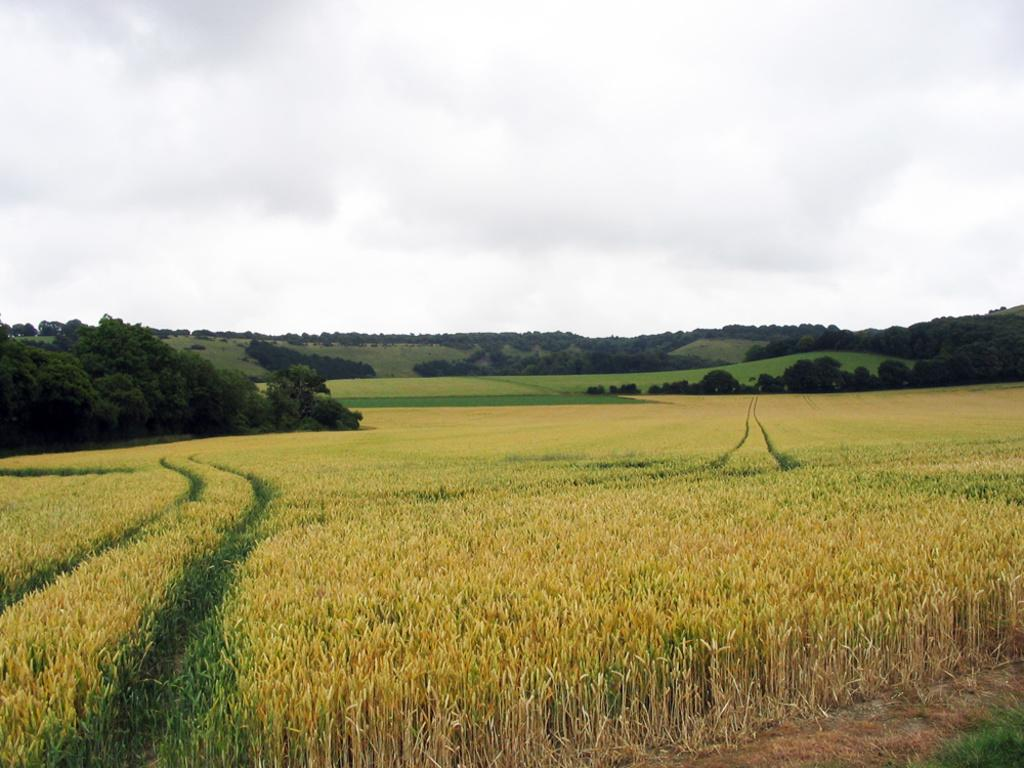What is the color of the grass in the image? The grass in the image is yellow. What can be seen in the background of the image? There are many trees, mountains, clouds, and the sky visible in the background of the image. What type of music is being played in the image? There is no music present in the image; it features a landscape with yellow grass, trees, mountains, clouds, and the sky. Can you tell me the author of the prose that is being read in the image? There is no prose or reading activity depicted in the image. 